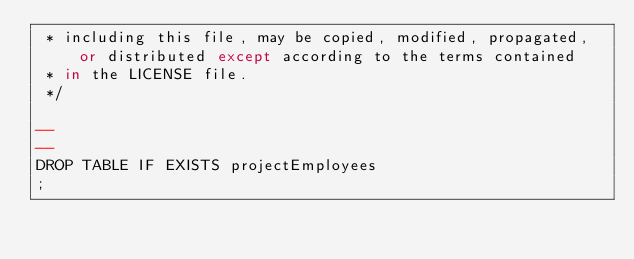Convert code to text. <code><loc_0><loc_0><loc_500><loc_500><_SQL_> * including this file, may be copied, modified, propagated, or distributed except according to the terms contained
 * in the LICENSE file.
 */

--
--
DROP TABLE IF EXISTS projectEmployees
;
</code> 